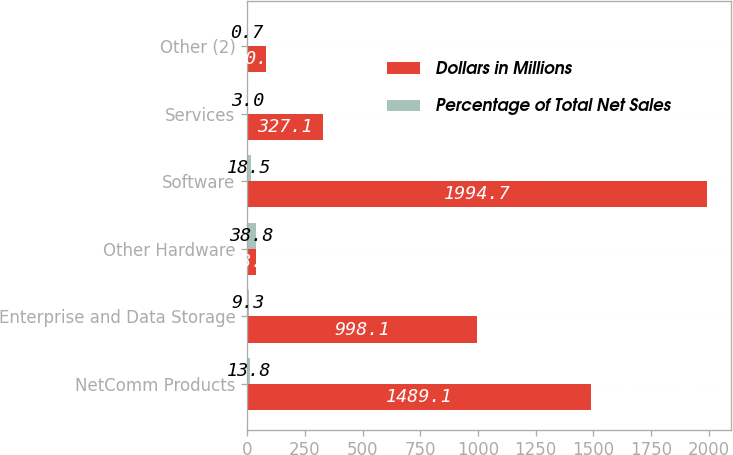Convert chart. <chart><loc_0><loc_0><loc_500><loc_500><stacked_bar_chart><ecel><fcel>NetComm Products<fcel>Enterprise and Data Storage<fcel>Other Hardware<fcel>Software<fcel>Services<fcel>Other (2)<nl><fcel>Dollars in Millions<fcel>1489.1<fcel>998.1<fcel>38.8<fcel>1994.7<fcel>327.1<fcel>80.3<nl><fcel>Percentage of Total Net Sales<fcel>13.8<fcel>9.3<fcel>38.8<fcel>18.5<fcel>3<fcel>0.7<nl></chart> 